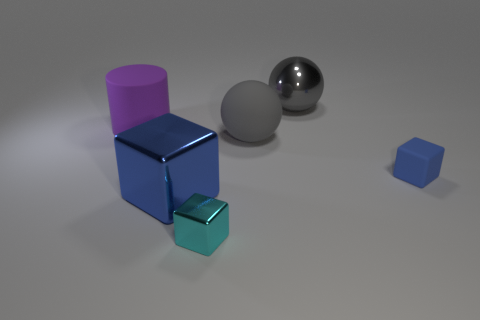What lighting conditions are depicted in the image? The lighting in the image appears to be diffused with a gentle overhead source, giving soft shadows that spread slightly away from the objects, indicating a controlled environment possibly simulating indirect daylight or studio lighting with softboxes to minimize harsh shadows and highlights. 